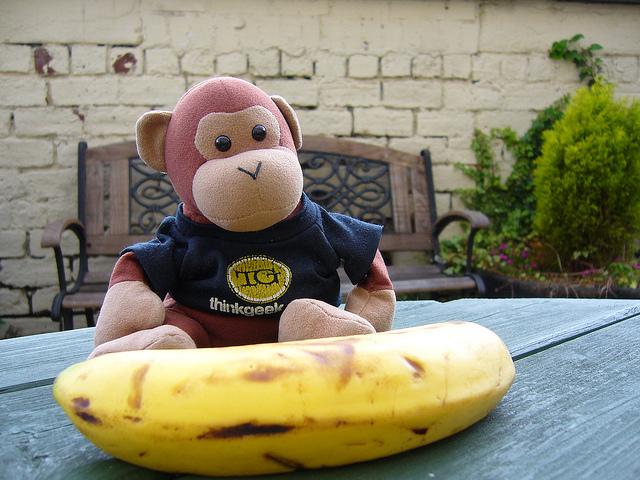Is the banana ripe?
Short answer required. Yes. Is the photo indoor or outdoor?
Write a very short answer. Outdoor. Is the animal in this picture real?
Short answer required. No. 